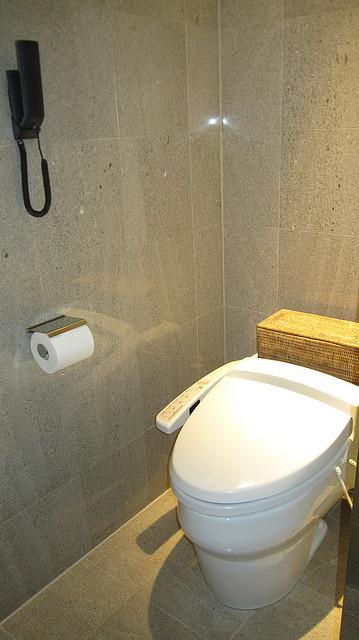What room is this?
Short answer required. Bathroom. What emergency system is in this room that someone might use if they had a stroke?
Short answer required. Phone. What color is the phone?
Short answer required. Black. 